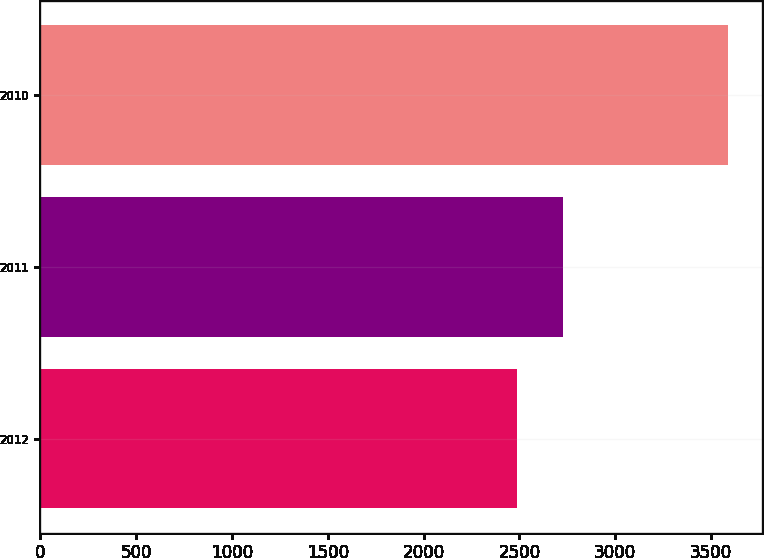Convert chart to OTSL. <chart><loc_0><loc_0><loc_500><loc_500><bar_chart><fcel>2012<fcel>2011<fcel>2010<nl><fcel>2489<fcel>2727<fcel>3587<nl></chart> 